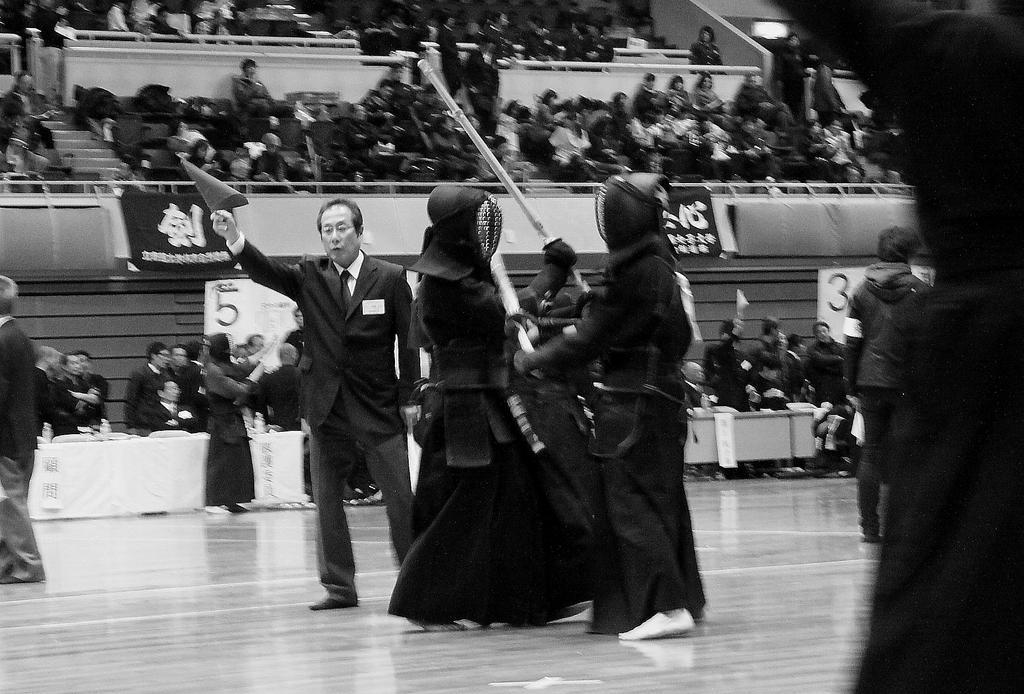How would you summarize this image in a sentence or two? In this picture we can see a group of girls wearing black color gown fighting in the stadium ground. Beside we can see a man wearing black color coat standing. In the background we can see a stadium with many chairs and a group of audience sitting and enjoying the game. 